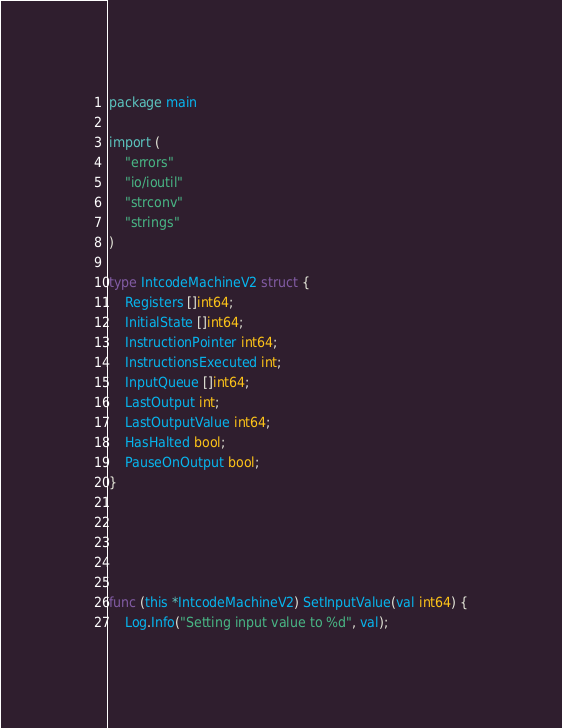Convert code to text. <code><loc_0><loc_0><loc_500><loc_500><_Go_>package main

import (
	"errors"
	"io/ioutil"
	"strconv"
	"strings"
)

type IntcodeMachineV2 struct {
	Registers []int64;
	InitialState []int64;
	InstructionPointer int64;
	InstructionsExecuted int;
	InputQueue []int64;
	LastOutput int;
	LastOutputValue int64;
	HasHalted bool;
	PauseOnOutput bool;
}





func (this *IntcodeMachineV2) SetInputValue(val int64) {
	Log.Info("Setting input value to %d", val);</code> 